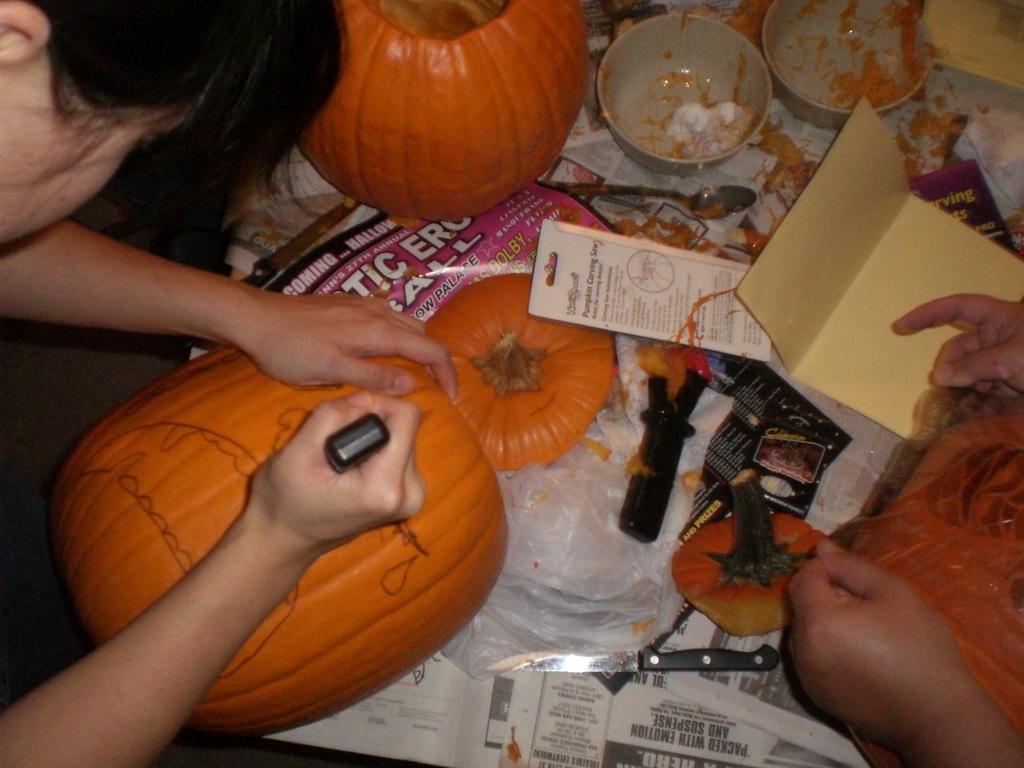Can you describe this image briefly? In this image, at the left side there is a woman sitting and she is holding a marker, at the right side we can see two hands of a person, there are some objects and we can see two bowls. 